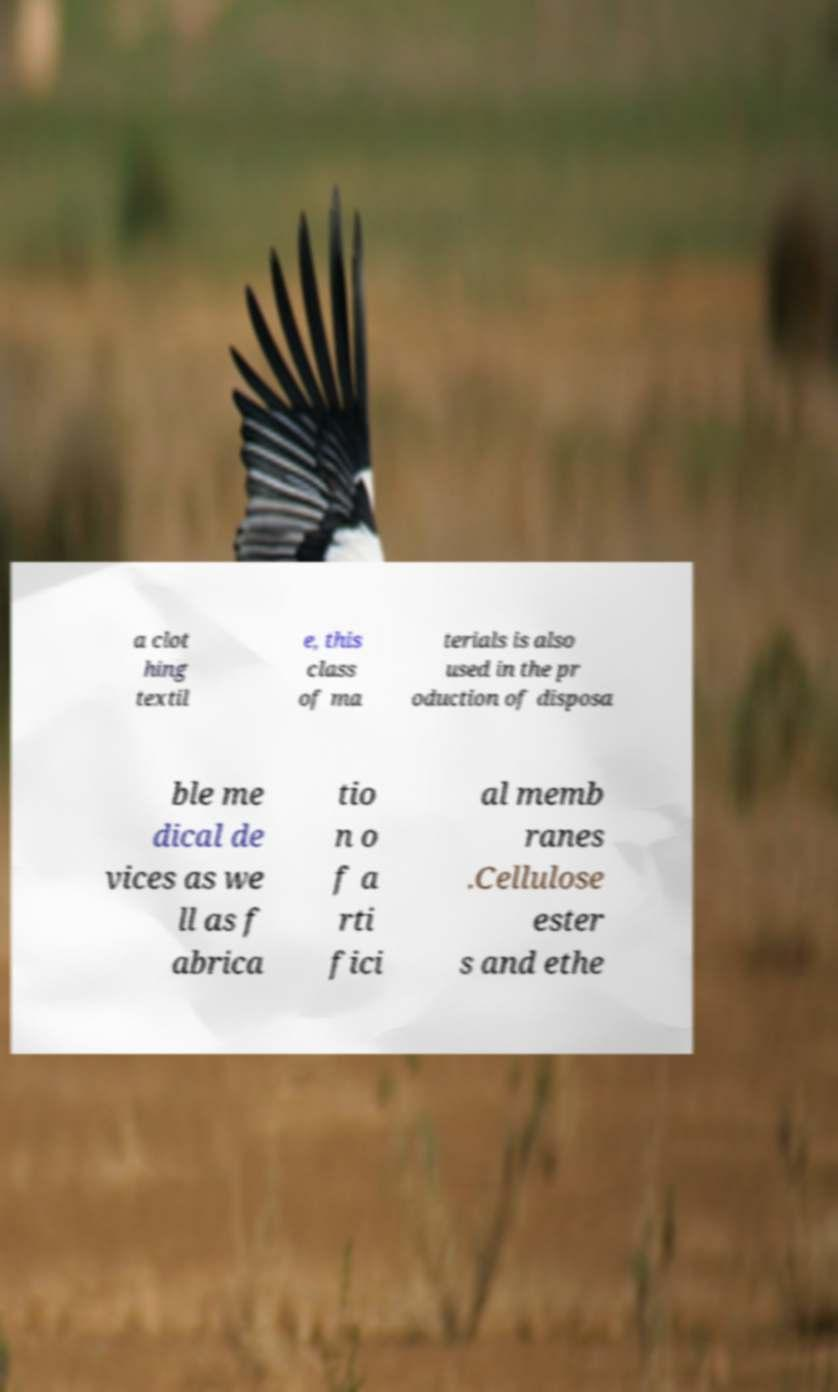Please identify and transcribe the text found in this image. a clot hing textil e, this class of ma terials is also used in the pr oduction of disposa ble me dical de vices as we ll as f abrica tio n o f a rti fici al memb ranes .Cellulose ester s and ethe 